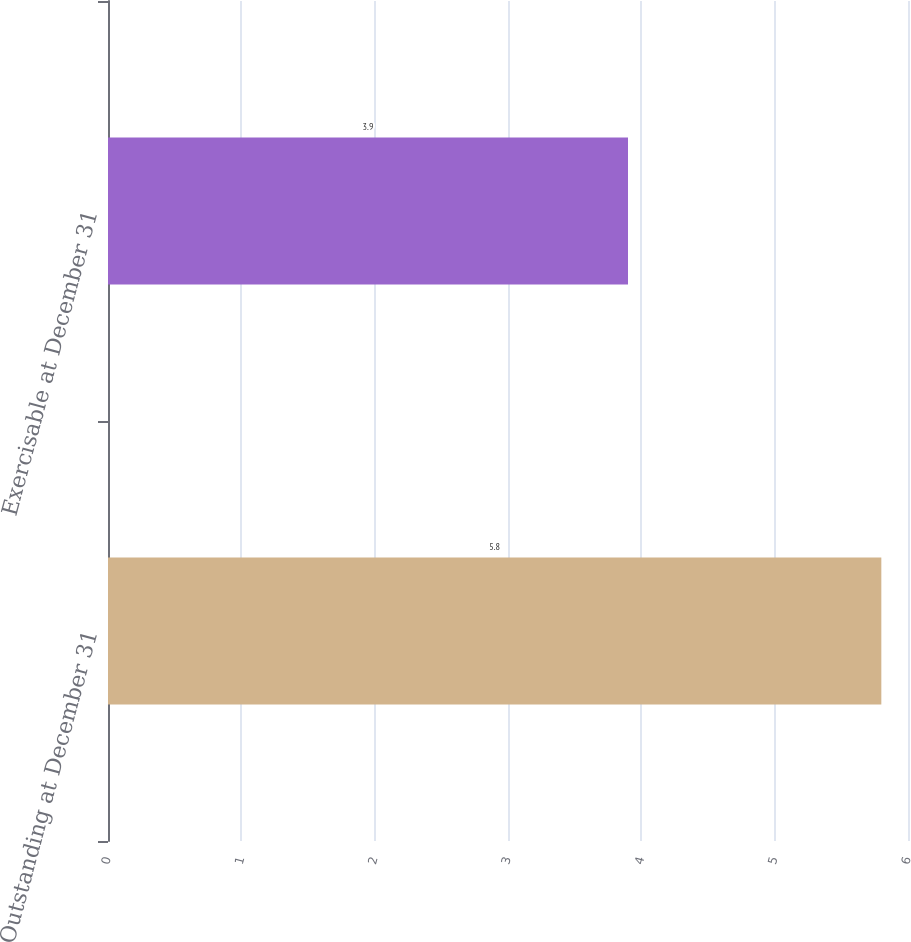Convert chart to OTSL. <chart><loc_0><loc_0><loc_500><loc_500><bar_chart><fcel>Outstanding at December 31<fcel>Exercisable at December 31<nl><fcel>5.8<fcel>3.9<nl></chart> 